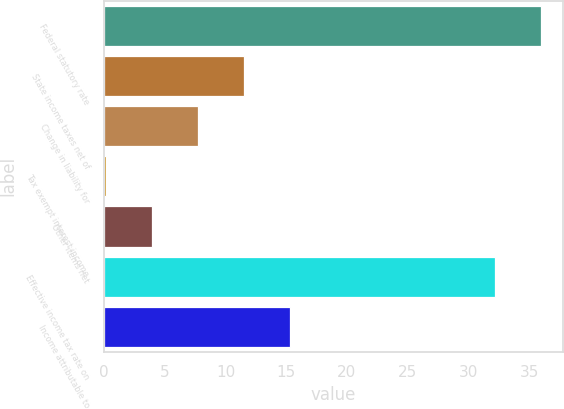Convert chart. <chart><loc_0><loc_0><loc_500><loc_500><bar_chart><fcel>Federal statutory rate<fcel>State income taxes net of<fcel>Change in liability for<fcel>Tax exempt interest income<fcel>Other items net<fcel>Effective income tax rate on<fcel>Income attributable to<nl><fcel>35.97<fcel>11.51<fcel>7.74<fcel>0.2<fcel>3.97<fcel>32.2<fcel>15.28<nl></chart> 